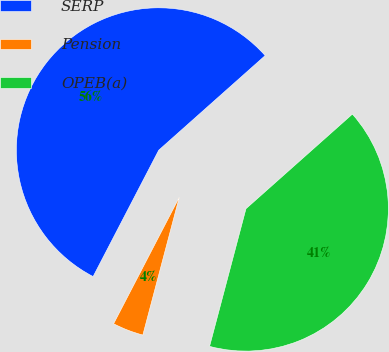Convert chart. <chart><loc_0><loc_0><loc_500><loc_500><pie_chart><fcel>SERP<fcel>Pension<fcel>OPEB(a)<nl><fcel>55.81%<fcel>3.51%<fcel>40.68%<nl></chart> 